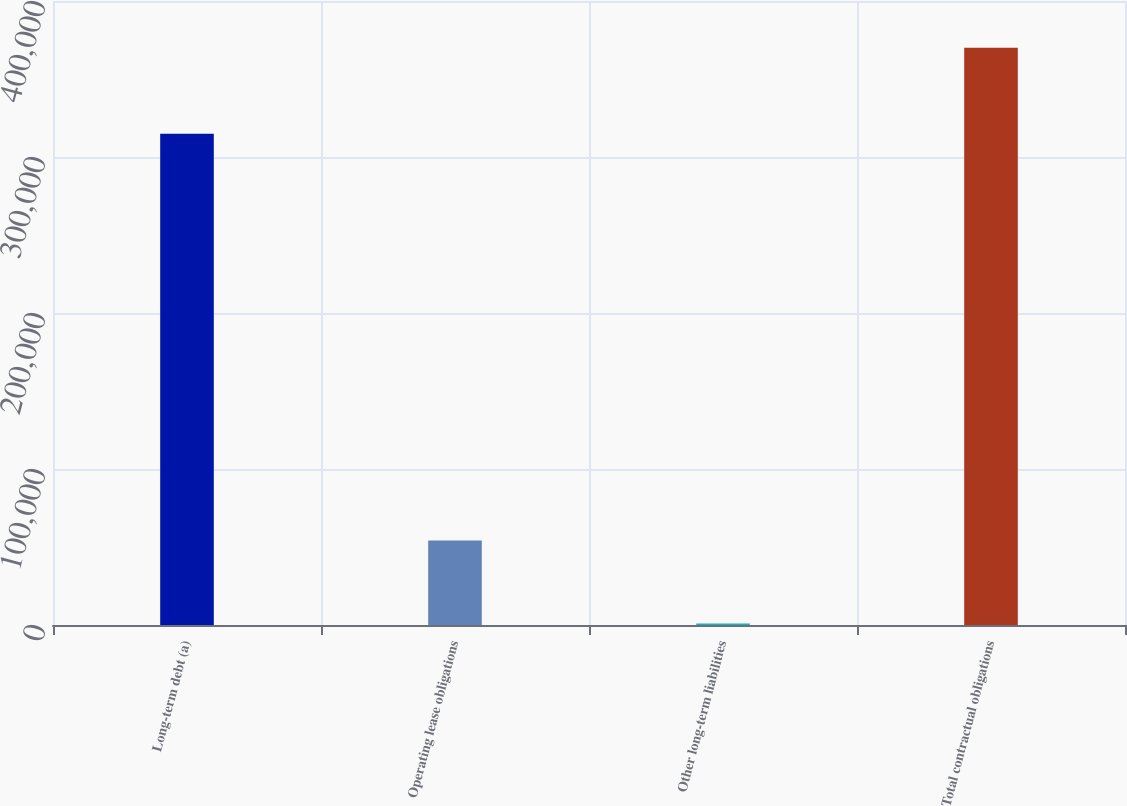Convert chart. <chart><loc_0><loc_0><loc_500><loc_500><bar_chart><fcel>Long-term debt (a)<fcel>Operating lease obligations<fcel>Other long-term liabilities<fcel>Total contractual obligations<nl><fcel>314937<fcel>54162<fcel>990<fcel>370089<nl></chart> 